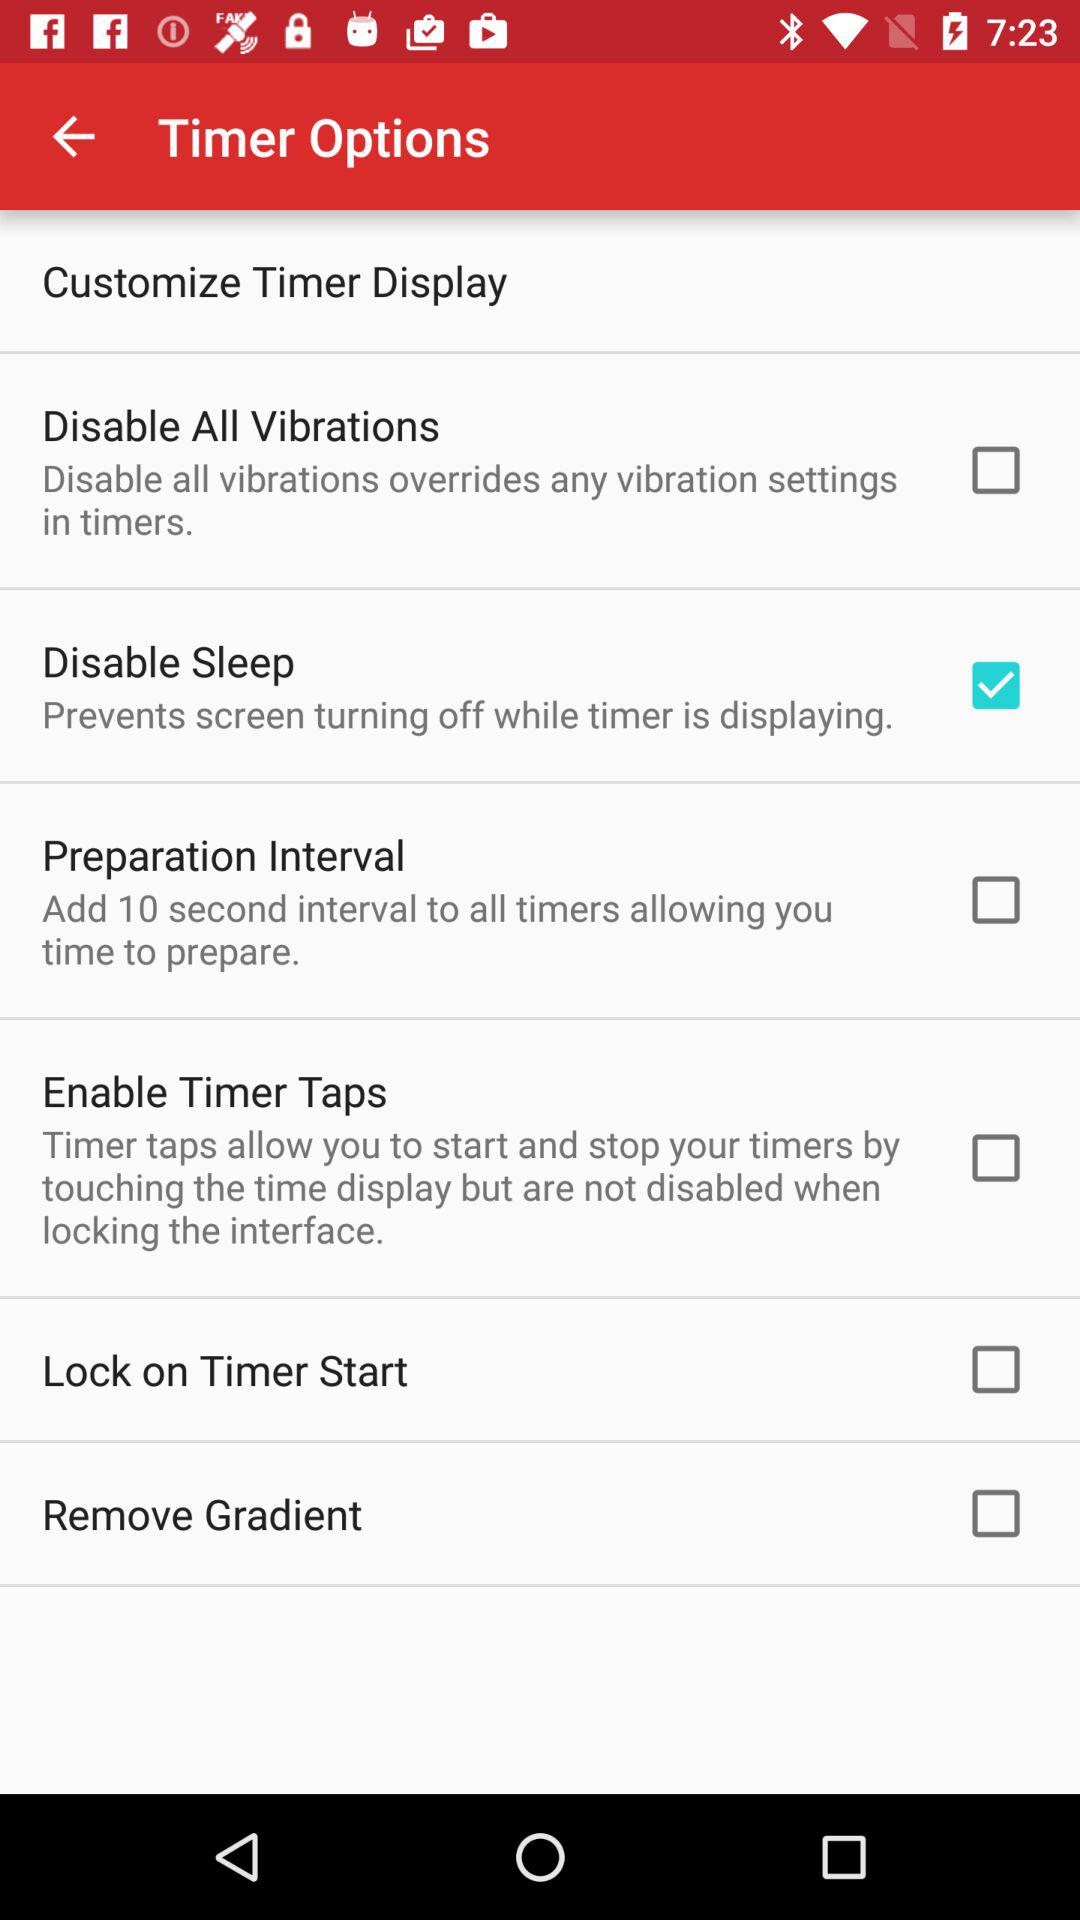What's the status of the "Lock on Timer Start"? The status of the "Lock on Timer Start" is "off". 